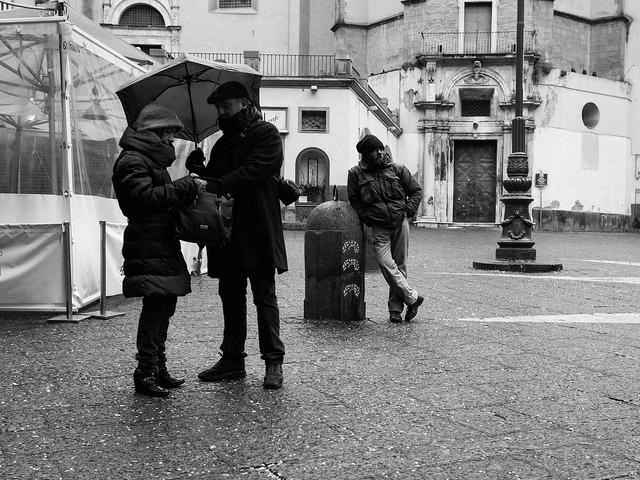What is the man standing on?
Quick response, please. Pavement. Is the a new photo?
Give a very brief answer. No. What color is the umbrella of the person on the left side of the picture?
Short answer required. Black. What are they looking at?
Keep it brief. Bag. How many hold skateboards?
Give a very brief answer. 0. Are there skateboards in the photo?
Quick response, please. No. What is the man doing to the woman?
Answer briefly. Talking. Where are they going?
Short answer required. Work. What is he waiting for?
Write a very short answer. Bus. Where is the couple going?
Be succinct. Home. Is the man traveling?
Keep it brief. No. What type of shoes are both people wearing?
Keep it brief. Boots. How old is this picture?
Short answer required. Recent. Is there a lot of traffic?
Give a very brief answer. No. Does the temperature appear over 75 degrees Fahrenheit?
Keep it brief. No. What is the color of the man's clothes?
Concise answer only. Black. What is the man on the left doing?
Answer briefly. Holding umbrella. What happened to the man's umbrella?
Give a very brief answer. Opened. What is the woman looking down at?
Quick response, please. Purse. Is this in black and white?
Keep it brief. Yes. Are the both people holding a umbrella?
Give a very brief answer. No. What color shoes is the woman with the white umbrella wearing?
Short answer required. Black. Does the woman appear to use the umbrella to shield herself from sun or rain?
Keep it brief. Rain. What are the people doing?
Keep it brief. Standing. 